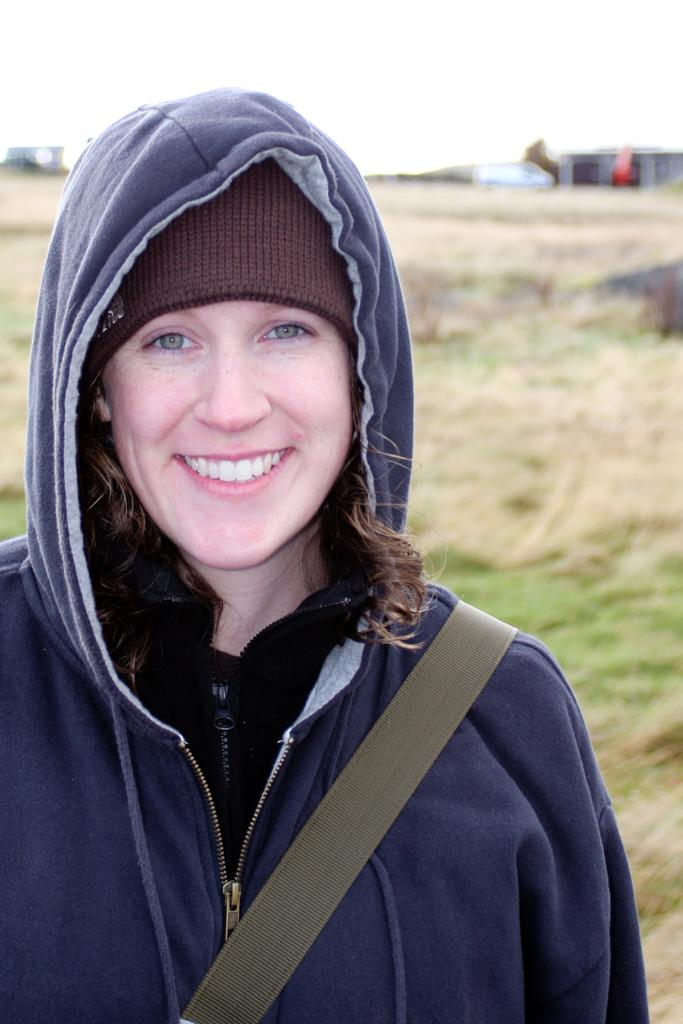Who is in the picture? There is a woman in the picture. What is the woman doing in the picture? The woman is smiling in the picture. What is the woman wearing on her head? The woman is wearing a cap in the picture. What can be seen in the background of the image? There are houses visible in the background of the image. What type of ground is present in the image? Grass is present on the ground in the image. How would you describe the sky in the image? The sky is cloudy in the image. What type of neck accessory is the woman wearing in the image? There is no neck accessory mentioned in the facts provided, so we cannot determine what type of neck accessory the woman is wearing in the image. --- Facts: 1. There is a car in the image. 2. The car is red. 3. The car has four wheels. 4. There are people in the car. 5. The car is parked on the street. 6. There are trees visible in the background of the image. Absurd Topics: fish, mountain, umbrella Conversation: What is the main subject of the image? The main subject of the image is a car. What color is the car? The car is red. How many wheels does the car have? The car has four wheels. Who is inside the car? There are people in the car. Where is the car located in the image? The car is parked on the street. What can be seen in the background of the image? There are trees visible in the background of the image. Reasoning: Let's think step by step in order to produce the conversation. We start by identifying the main subject in the image, which is the car. Then, we describe the car's color, number of wheels, and occupants. We also mention the car's location and the background elements. Each question is designed to elicit a specific detail about the image that is known from the provided facts. Absurd Question/Answer: Can you see any fish swimming in the car in the image? No, there are no fish visible in the car or the image. 